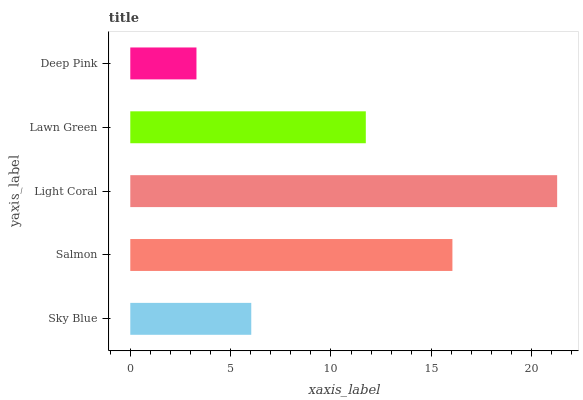Is Deep Pink the minimum?
Answer yes or no. Yes. Is Light Coral the maximum?
Answer yes or no. Yes. Is Salmon the minimum?
Answer yes or no. No. Is Salmon the maximum?
Answer yes or no. No. Is Salmon greater than Sky Blue?
Answer yes or no. Yes. Is Sky Blue less than Salmon?
Answer yes or no. Yes. Is Sky Blue greater than Salmon?
Answer yes or no. No. Is Salmon less than Sky Blue?
Answer yes or no. No. Is Lawn Green the high median?
Answer yes or no. Yes. Is Lawn Green the low median?
Answer yes or no. Yes. Is Deep Pink the high median?
Answer yes or no. No. Is Deep Pink the low median?
Answer yes or no. No. 